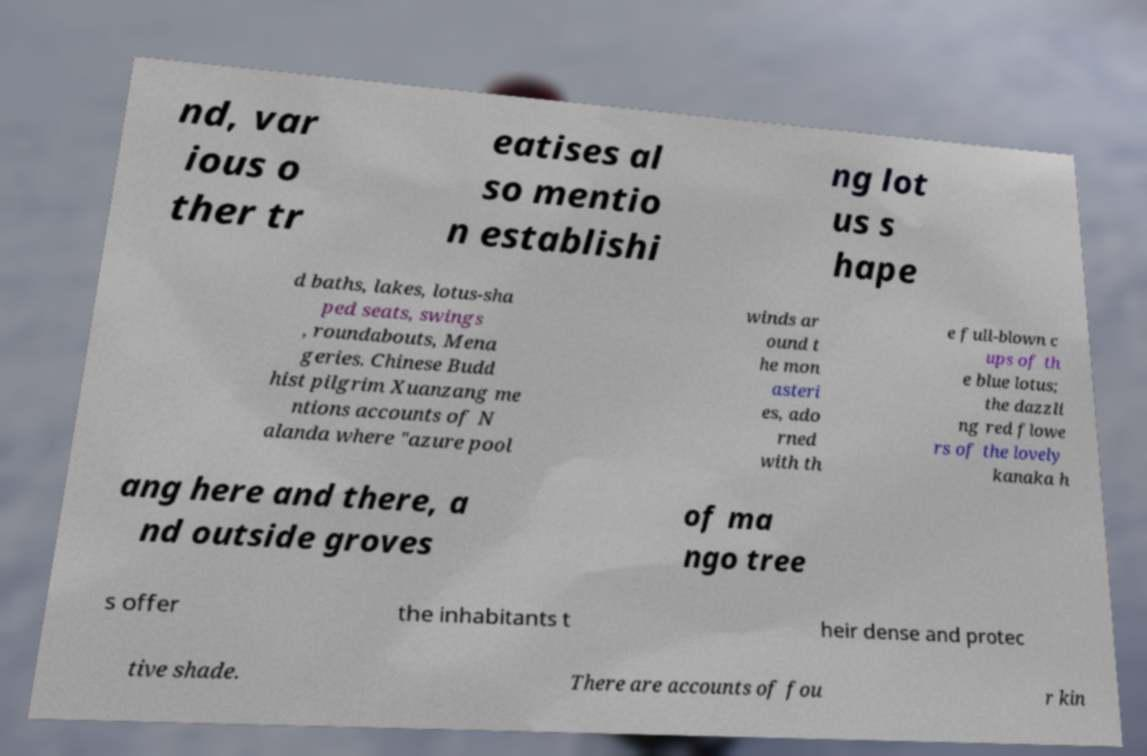There's text embedded in this image that I need extracted. Can you transcribe it verbatim? nd, var ious o ther tr eatises al so mentio n establishi ng lot us s hape d baths, lakes, lotus-sha ped seats, swings , roundabouts, Mena geries. Chinese Budd hist pilgrim Xuanzang me ntions accounts of N alanda where "azure pool winds ar ound t he mon asteri es, ado rned with th e full-blown c ups of th e blue lotus; the dazzli ng red flowe rs of the lovely kanaka h ang here and there, a nd outside groves of ma ngo tree s offer the inhabitants t heir dense and protec tive shade. There are accounts of fou r kin 